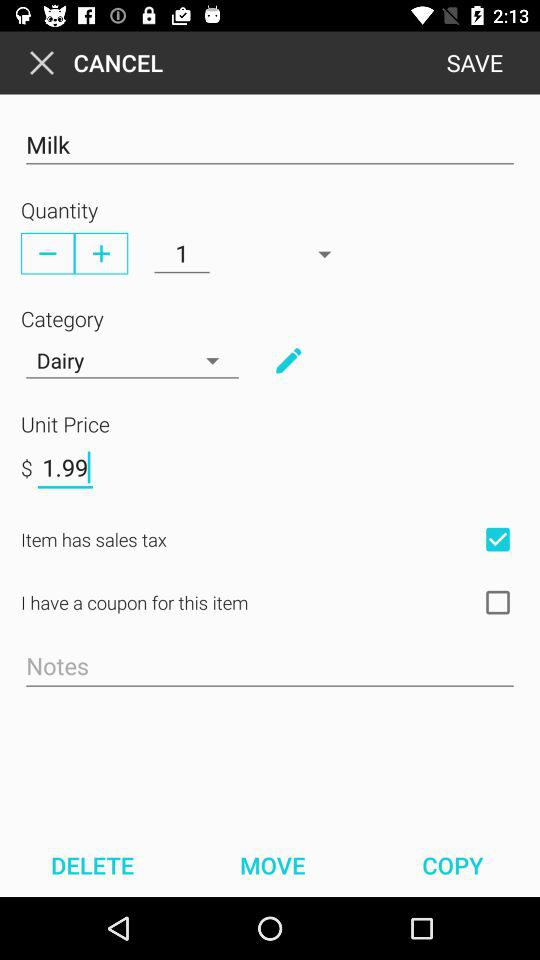Is "Item has sales tax" checked or unchecked? "Item has sales tax" is checked. 